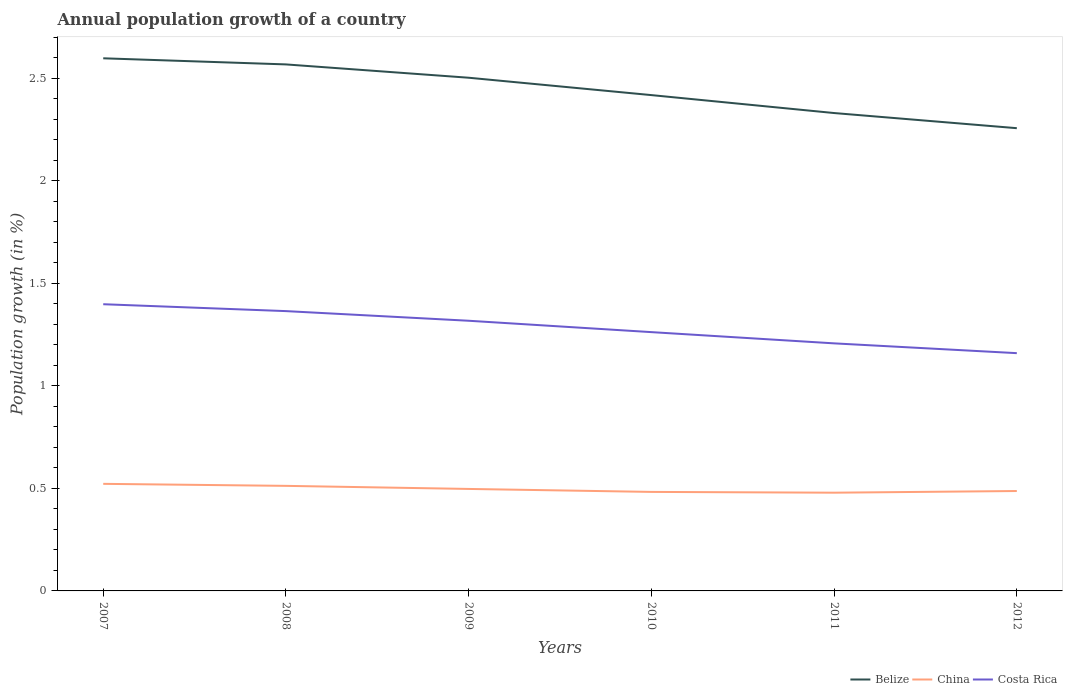How many different coloured lines are there?
Make the answer very short. 3. Does the line corresponding to Belize intersect with the line corresponding to China?
Provide a succinct answer. No. Is the number of lines equal to the number of legend labels?
Your answer should be very brief. Yes. Across all years, what is the maximum annual population growth in Costa Rica?
Give a very brief answer. 1.16. What is the total annual population growth in China in the graph?
Your answer should be compact. 0.02. What is the difference between the highest and the second highest annual population growth in China?
Your answer should be very brief. 0.04. Is the annual population growth in China strictly greater than the annual population growth in Costa Rica over the years?
Ensure brevity in your answer.  Yes. Does the graph contain any zero values?
Your answer should be compact. No. Does the graph contain grids?
Your answer should be compact. No. How are the legend labels stacked?
Your answer should be compact. Horizontal. What is the title of the graph?
Give a very brief answer. Annual population growth of a country. What is the label or title of the X-axis?
Make the answer very short. Years. What is the label or title of the Y-axis?
Your answer should be very brief. Population growth (in %). What is the Population growth (in %) in Belize in 2007?
Provide a short and direct response. 2.6. What is the Population growth (in %) of China in 2007?
Keep it short and to the point. 0.52. What is the Population growth (in %) of Costa Rica in 2007?
Your answer should be compact. 1.4. What is the Population growth (in %) of Belize in 2008?
Make the answer very short. 2.57. What is the Population growth (in %) in China in 2008?
Give a very brief answer. 0.51. What is the Population growth (in %) of Costa Rica in 2008?
Keep it short and to the point. 1.36. What is the Population growth (in %) of Belize in 2009?
Make the answer very short. 2.5. What is the Population growth (in %) of China in 2009?
Your answer should be very brief. 0.5. What is the Population growth (in %) in Costa Rica in 2009?
Your answer should be compact. 1.32. What is the Population growth (in %) of Belize in 2010?
Provide a succinct answer. 2.42. What is the Population growth (in %) of China in 2010?
Keep it short and to the point. 0.48. What is the Population growth (in %) in Costa Rica in 2010?
Provide a succinct answer. 1.26. What is the Population growth (in %) in Belize in 2011?
Keep it short and to the point. 2.33. What is the Population growth (in %) of China in 2011?
Provide a succinct answer. 0.48. What is the Population growth (in %) in Costa Rica in 2011?
Your response must be concise. 1.21. What is the Population growth (in %) in Belize in 2012?
Your answer should be very brief. 2.26. What is the Population growth (in %) of China in 2012?
Provide a succinct answer. 0.49. What is the Population growth (in %) in Costa Rica in 2012?
Your response must be concise. 1.16. Across all years, what is the maximum Population growth (in %) of Belize?
Your answer should be very brief. 2.6. Across all years, what is the maximum Population growth (in %) of China?
Make the answer very short. 0.52. Across all years, what is the maximum Population growth (in %) in Costa Rica?
Your response must be concise. 1.4. Across all years, what is the minimum Population growth (in %) in Belize?
Provide a short and direct response. 2.26. Across all years, what is the minimum Population growth (in %) in China?
Your answer should be compact. 0.48. Across all years, what is the minimum Population growth (in %) of Costa Rica?
Keep it short and to the point. 1.16. What is the total Population growth (in %) of Belize in the graph?
Your response must be concise. 14.67. What is the total Population growth (in %) of China in the graph?
Offer a very short reply. 2.98. What is the total Population growth (in %) in Costa Rica in the graph?
Your answer should be very brief. 7.71. What is the difference between the Population growth (in %) in Belize in 2007 and that in 2008?
Ensure brevity in your answer.  0.03. What is the difference between the Population growth (in %) of China in 2007 and that in 2008?
Offer a terse response. 0.01. What is the difference between the Population growth (in %) of Costa Rica in 2007 and that in 2008?
Provide a short and direct response. 0.03. What is the difference between the Population growth (in %) in Belize in 2007 and that in 2009?
Provide a short and direct response. 0.09. What is the difference between the Population growth (in %) of China in 2007 and that in 2009?
Keep it short and to the point. 0.02. What is the difference between the Population growth (in %) in Costa Rica in 2007 and that in 2009?
Your answer should be very brief. 0.08. What is the difference between the Population growth (in %) of Belize in 2007 and that in 2010?
Provide a short and direct response. 0.18. What is the difference between the Population growth (in %) in China in 2007 and that in 2010?
Your answer should be compact. 0.04. What is the difference between the Population growth (in %) in Costa Rica in 2007 and that in 2010?
Your response must be concise. 0.14. What is the difference between the Population growth (in %) of Belize in 2007 and that in 2011?
Keep it short and to the point. 0.27. What is the difference between the Population growth (in %) of China in 2007 and that in 2011?
Give a very brief answer. 0.04. What is the difference between the Population growth (in %) of Costa Rica in 2007 and that in 2011?
Your answer should be compact. 0.19. What is the difference between the Population growth (in %) in Belize in 2007 and that in 2012?
Provide a short and direct response. 0.34. What is the difference between the Population growth (in %) of China in 2007 and that in 2012?
Provide a short and direct response. 0.04. What is the difference between the Population growth (in %) of Costa Rica in 2007 and that in 2012?
Offer a terse response. 0.24. What is the difference between the Population growth (in %) in Belize in 2008 and that in 2009?
Keep it short and to the point. 0.06. What is the difference between the Population growth (in %) in China in 2008 and that in 2009?
Give a very brief answer. 0.01. What is the difference between the Population growth (in %) of Costa Rica in 2008 and that in 2009?
Keep it short and to the point. 0.05. What is the difference between the Population growth (in %) in Belize in 2008 and that in 2010?
Your answer should be compact. 0.15. What is the difference between the Population growth (in %) of China in 2008 and that in 2010?
Provide a short and direct response. 0.03. What is the difference between the Population growth (in %) in Costa Rica in 2008 and that in 2010?
Give a very brief answer. 0.1. What is the difference between the Population growth (in %) in Belize in 2008 and that in 2011?
Keep it short and to the point. 0.24. What is the difference between the Population growth (in %) of China in 2008 and that in 2011?
Provide a short and direct response. 0.03. What is the difference between the Population growth (in %) of Costa Rica in 2008 and that in 2011?
Provide a succinct answer. 0.16. What is the difference between the Population growth (in %) in Belize in 2008 and that in 2012?
Ensure brevity in your answer.  0.31. What is the difference between the Population growth (in %) in China in 2008 and that in 2012?
Provide a short and direct response. 0.03. What is the difference between the Population growth (in %) of Costa Rica in 2008 and that in 2012?
Offer a very short reply. 0.21. What is the difference between the Population growth (in %) of Belize in 2009 and that in 2010?
Make the answer very short. 0.08. What is the difference between the Population growth (in %) of China in 2009 and that in 2010?
Your answer should be compact. 0.01. What is the difference between the Population growth (in %) in Costa Rica in 2009 and that in 2010?
Your answer should be very brief. 0.06. What is the difference between the Population growth (in %) of Belize in 2009 and that in 2011?
Make the answer very short. 0.17. What is the difference between the Population growth (in %) in China in 2009 and that in 2011?
Offer a terse response. 0.02. What is the difference between the Population growth (in %) in Costa Rica in 2009 and that in 2011?
Offer a very short reply. 0.11. What is the difference between the Population growth (in %) in Belize in 2009 and that in 2012?
Make the answer very short. 0.25. What is the difference between the Population growth (in %) of China in 2009 and that in 2012?
Your response must be concise. 0.01. What is the difference between the Population growth (in %) in Costa Rica in 2009 and that in 2012?
Offer a terse response. 0.16. What is the difference between the Population growth (in %) in Belize in 2010 and that in 2011?
Give a very brief answer. 0.09. What is the difference between the Population growth (in %) of China in 2010 and that in 2011?
Keep it short and to the point. 0. What is the difference between the Population growth (in %) of Costa Rica in 2010 and that in 2011?
Your answer should be compact. 0.05. What is the difference between the Population growth (in %) of Belize in 2010 and that in 2012?
Your answer should be very brief. 0.16. What is the difference between the Population growth (in %) of China in 2010 and that in 2012?
Offer a terse response. -0. What is the difference between the Population growth (in %) in Costa Rica in 2010 and that in 2012?
Ensure brevity in your answer.  0.1. What is the difference between the Population growth (in %) in Belize in 2011 and that in 2012?
Your response must be concise. 0.07. What is the difference between the Population growth (in %) in China in 2011 and that in 2012?
Your response must be concise. -0.01. What is the difference between the Population growth (in %) in Costa Rica in 2011 and that in 2012?
Your response must be concise. 0.05. What is the difference between the Population growth (in %) in Belize in 2007 and the Population growth (in %) in China in 2008?
Offer a very short reply. 2.09. What is the difference between the Population growth (in %) of Belize in 2007 and the Population growth (in %) of Costa Rica in 2008?
Provide a short and direct response. 1.23. What is the difference between the Population growth (in %) of China in 2007 and the Population growth (in %) of Costa Rica in 2008?
Your answer should be very brief. -0.84. What is the difference between the Population growth (in %) of Belize in 2007 and the Population growth (in %) of China in 2009?
Offer a terse response. 2.1. What is the difference between the Population growth (in %) of Belize in 2007 and the Population growth (in %) of Costa Rica in 2009?
Offer a very short reply. 1.28. What is the difference between the Population growth (in %) of China in 2007 and the Population growth (in %) of Costa Rica in 2009?
Provide a short and direct response. -0.8. What is the difference between the Population growth (in %) in Belize in 2007 and the Population growth (in %) in China in 2010?
Give a very brief answer. 2.11. What is the difference between the Population growth (in %) of Belize in 2007 and the Population growth (in %) of Costa Rica in 2010?
Your response must be concise. 1.34. What is the difference between the Population growth (in %) of China in 2007 and the Population growth (in %) of Costa Rica in 2010?
Provide a succinct answer. -0.74. What is the difference between the Population growth (in %) of Belize in 2007 and the Population growth (in %) of China in 2011?
Make the answer very short. 2.12. What is the difference between the Population growth (in %) of Belize in 2007 and the Population growth (in %) of Costa Rica in 2011?
Keep it short and to the point. 1.39. What is the difference between the Population growth (in %) of China in 2007 and the Population growth (in %) of Costa Rica in 2011?
Offer a very short reply. -0.69. What is the difference between the Population growth (in %) in Belize in 2007 and the Population growth (in %) in China in 2012?
Ensure brevity in your answer.  2.11. What is the difference between the Population growth (in %) in Belize in 2007 and the Population growth (in %) in Costa Rica in 2012?
Keep it short and to the point. 1.44. What is the difference between the Population growth (in %) of China in 2007 and the Population growth (in %) of Costa Rica in 2012?
Give a very brief answer. -0.64. What is the difference between the Population growth (in %) of Belize in 2008 and the Population growth (in %) of China in 2009?
Your answer should be very brief. 2.07. What is the difference between the Population growth (in %) of Belize in 2008 and the Population growth (in %) of Costa Rica in 2009?
Offer a very short reply. 1.25. What is the difference between the Population growth (in %) of China in 2008 and the Population growth (in %) of Costa Rica in 2009?
Your answer should be compact. -0.81. What is the difference between the Population growth (in %) in Belize in 2008 and the Population growth (in %) in China in 2010?
Offer a very short reply. 2.08. What is the difference between the Population growth (in %) in Belize in 2008 and the Population growth (in %) in Costa Rica in 2010?
Offer a terse response. 1.31. What is the difference between the Population growth (in %) in China in 2008 and the Population growth (in %) in Costa Rica in 2010?
Make the answer very short. -0.75. What is the difference between the Population growth (in %) of Belize in 2008 and the Population growth (in %) of China in 2011?
Give a very brief answer. 2.09. What is the difference between the Population growth (in %) in Belize in 2008 and the Population growth (in %) in Costa Rica in 2011?
Offer a terse response. 1.36. What is the difference between the Population growth (in %) of China in 2008 and the Population growth (in %) of Costa Rica in 2011?
Provide a succinct answer. -0.7. What is the difference between the Population growth (in %) in Belize in 2008 and the Population growth (in %) in China in 2012?
Give a very brief answer. 2.08. What is the difference between the Population growth (in %) of Belize in 2008 and the Population growth (in %) of Costa Rica in 2012?
Ensure brevity in your answer.  1.41. What is the difference between the Population growth (in %) in China in 2008 and the Population growth (in %) in Costa Rica in 2012?
Your response must be concise. -0.65. What is the difference between the Population growth (in %) in Belize in 2009 and the Population growth (in %) in China in 2010?
Give a very brief answer. 2.02. What is the difference between the Population growth (in %) in Belize in 2009 and the Population growth (in %) in Costa Rica in 2010?
Provide a short and direct response. 1.24. What is the difference between the Population growth (in %) of China in 2009 and the Population growth (in %) of Costa Rica in 2010?
Offer a very short reply. -0.76. What is the difference between the Population growth (in %) of Belize in 2009 and the Population growth (in %) of China in 2011?
Provide a short and direct response. 2.02. What is the difference between the Population growth (in %) of Belize in 2009 and the Population growth (in %) of Costa Rica in 2011?
Offer a terse response. 1.3. What is the difference between the Population growth (in %) of China in 2009 and the Population growth (in %) of Costa Rica in 2011?
Provide a short and direct response. -0.71. What is the difference between the Population growth (in %) of Belize in 2009 and the Population growth (in %) of China in 2012?
Offer a terse response. 2.02. What is the difference between the Population growth (in %) in Belize in 2009 and the Population growth (in %) in Costa Rica in 2012?
Offer a very short reply. 1.34. What is the difference between the Population growth (in %) in China in 2009 and the Population growth (in %) in Costa Rica in 2012?
Provide a short and direct response. -0.66. What is the difference between the Population growth (in %) in Belize in 2010 and the Population growth (in %) in China in 2011?
Ensure brevity in your answer.  1.94. What is the difference between the Population growth (in %) of Belize in 2010 and the Population growth (in %) of Costa Rica in 2011?
Give a very brief answer. 1.21. What is the difference between the Population growth (in %) of China in 2010 and the Population growth (in %) of Costa Rica in 2011?
Make the answer very short. -0.72. What is the difference between the Population growth (in %) of Belize in 2010 and the Population growth (in %) of China in 2012?
Ensure brevity in your answer.  1.93. What is the difference between the Population growth (in %) in Belize in 2010 and the Population growth (in %) in Costa Rica in 2012?
Offer a terse response. 1.26. What is the difference between the Population growth (in %) in China in 2010 and the Population growth (in %) in Costa Rica in 2012?
Offer a very short reply. -0.68. What is the difference between the Population growth (in %) in Belize in 2011 and the Population growth (in %) in China in 2012?
Offer a terse response. 1.84. What is the difference between the Population growth (in %) in Belize in 2011 and the Population growth (in %) in Costa Rica in 2012?
Your response must be concise. 1.17. What is the difference between the Population growth (in %) of China in 2011 and the Population growth (in %) of Costa Rica in 2012?
Ensure brevity in your answer.  -0.68. What is the average Population growth (in %) in Belize per year?
Your answer should be compact. 2.45. What is the average Population growth (in %) of China per year?
Offer a very short reply. 0.5. What is the average Population growth (in %) in Costa Rica per year?
Ensure brevity in your answer.  1.28. In the year 2007, what is the difference between the Population growth (in %) of Belize and Population growth (in %) of China?
Provide a succinct answer. 2.08. In the year 2007, what is the difference between the Population growth (in %) in Belize and Population growth (in %) in Costa Rica?
Give a very brief answer. 1.2. In the year 2007, what is the difference between the Population growth (in %) of China and Population growth (in %) of Costa Rica?
Make the answer very short. -0.88. In the year 2008, what is the difference between the Population growth (in %) in Belize and Population growth (in %) in China?
Your answer should be very brief. 2.06. In the year 2008, what is the difference between the Population growth (in %) in Belize and Population growth (in %) in Costa Rica?
Your answer should be very brief. 1.2. In the year 2008, what is the difference between the Population growth (in %) of China and Population growth (in %) of Costa Rica?
Keep it short and to the point. -0.85. In the year 2009, what is the difference between the Population growth (in %) of Belize and Population growth (in %) of China?
Offer a very short reply. 2.01. In the year 2009, what is the difference between the Population growth (in %) of Belize and Population growth (in %) of Costa Rica?
Keep it short and to the point. 1.19. In the year 2009, what is the difference between the Population growth (in %) in China and Population growth (in %) in Costa Rica?
Provide a succinct answer. -0.82. In the year 2010, what is the difference between the Population growth (in %) of Belize and Population growth (in %) of China?
Keep it short and to the point. 1.94. In the year 2010, what is the difference between the Population growth (in %) in Belize and Population growth (in %) in Costa Rica?
Keep it short and to the point. 1.16. In the year 2010, what is the difference between the Population growth (in %) of China and Population growth (in %) of Costa Rica?
Ensure brevity in your answer.  -0.78. In the year 2011, what is the difference between the Population growth (in %) in Belize and Population growth (in %) in China?
Keep it short and to the point. 1.85. In the year 2011, what is the difference between the Population growth (in %) in Belize and Population growth (in %) in Costa Rica?
Provide a short and direct response. 1.12. In the year 2011, what is the difference between the Population growth (in %) of China and Population growth (in %) of Costa Rica?
Offer a very short reply. -0.73. In the year 2012, what is the difference between the Population growth (in %) in Belize and Population growth (in %) in China?
Offer a terse response. 1.77. In the year 2012, what is the difference between the Population growth (in %) in Belize and Population growth (in %) in Costa Rica?
Offer a terse response. 1.1. In the year 2012, what is the difference between the Population growth (in %) in China and Population growth (in %) in Costa Rica?
Offer a terse response. -0.67. What is the ratio of the Population growth (in %) in Belize in 2007 to that in 2008?
Make the answer very short. 1.01. What is the ratio of the Population growth (in %) of China in 2007 to that in 2008?
Ensure brevity in your answer.  1.02. What is the ratio of the Population growth (in %) in Costa Rica in 2007 to that in 2008?
Keep it short and to the point. 1.02. What is the ratio of the Population growth (in %) in Belize in 2007 to that in 2009?
Ensure brevity in your answer.  1.04. What is the ratio of the Population growth (in %) in Costa Rica in 2007 to that in 2009?
Your response must be concise. 1.06. What is the ratio of the Population growth (in %) of Belize in 2007 to that in 2010?
Your answer should be compact. 1.07. What is the ratio of the Population growth (in %) of China in 2007 to that in 2010?
Offer a very short reply. 1.08. What is the ratio of the Population growth (in %) of Costa Rica in 2007 to that in 2010?
Keep it short and to the point. 1.11. What is the ratio of the Population growth (in %) in Belize in 2007 to that in 2011?
Keep it short and to the point. 1.11. What is the ratio of the Population growth (in %) in China in 2007 to that in 2011?
Offer a very short reply. 1.09. What is the ratio of the Population growth (in %) in Costa Rica in 2007 to that in 2011?
Make the answer very short. 1.16. What is the ratio of the Population growth (in %) in Belize in 2007 to that in 2012?
Provide a succinct answer. 1.15. What is the ratio of the Population growth (in %) in China in 2007 to that in 2012?
Your response must be concise. 1.07. What is the ratio of the Population growth (in %) in Costa Rica in 2007 to that in 2012?
Offer a terse response. 1.21. What is the ratio of the Population growth (in %) of Belize in 2008 to that in 2009?
Make the answer very short. 1.03. What is the ratio of the Population growth (in %) in China in 2008 to that in 2009?
Your response must be concise. 1.03. What is the ratio of the Population growth (in %) of Costa Rica in 2008 to that in 2009?
Ensure brevity in your answer.  1.04. What is the ratio of the Population growth (in %) of Belize in 2008 to that in 2010?
Offer a very short reply. 1.06. What is the ratio of the Population growth (in %) of China in 2008 to that in 2010?
Offer a very short reply. 1.06. What is the ratio of the Population growth (in %) in Costa Rica in 2008 to that in 2010?
Your answer should be compact. 1.08. What is the ratio of the Population growth (in %) in Belize in 2008 to that in 2011?
Offer a very short reply. 1.1. What is the ratio of the Population growth (in %) in China in 2008 to that in 2011?
Keep it short and to the point. 1.07. What is the ratio of the Population growth (in %) of Costa Rica in 2008 to that in 2011?
Your answer should be compact. 1.13. What is the ratio of the Population growth (in %) in Belize in 2008 to that in 2012?
Provide a short and direct response. 1.14. What is the ratio of the Population growth (in %) of China in 2008 to that in 2012?
Make the answer very short. 1.05. What is the ratio of the Population growth (in %) of Costa Rica in 2008 to that in 2012?
Keep it short and to the point. 1.18. What is the ratio of the Population growth (in %) in Belize in 2009 to that in 2010?
Provide a short and direct response. 1.03. What is the ratio of the Population growth (in %) in China in 2009 to that in 2010?
Offer a terse response. 1.03. What is the ratio of the Population growth (in %) of Costa Rica in 2009 to that in 2010?
Provide a succinct answer. 1.04. What is the ratio of the Population growth (in %) in Belize in 2009 to that in 2011?
Your response must be concise. 1.07. What is the ratio of the Population growth (in %) in China in 2009 to that in 2011?
Provide a short and direct response. 1.04. What is the ratio of the Population growth (in %) of Costa Rica in 2009 to that in 2011?
Give a very brief answer. 1.09. What is the ratio of the Population growth (in %) of Belize in 2009 to that in 2012?
Your response must be concise. 1.11. What is the ratio of the Population growth (in %) in China in 2009 to that in 2012?
Make the answer very short. 1.02. What is the ratio of the Population growth (in %) in Costa Rica in 2009 to that in 2012?
Offer a terse response. 1.14. What is the ratio of the Population growth (in %) of Belize in 2010 to that in 2011?
Ensure brevity in your answer.  1.04. What is the ratio of the Population growth (in %) of China in 2010 to that in 2011?
Your answer should be very brief. 1.01. What is the ratio of the Population growth (in %) in Costa Rica in 2010 to that in 2011?
Offer a terse response. 1.05. What is the ratio of the Population growth (in %) of Belize in 2010 to that in 2012?
Offer a terse response. 1.07. What is the ratio of the Population growth (in %) of China in 2010 to that in 2012?
Offer a very short reply. 0.99. What is the ratio of the Population growth (in %) in Costa Rica in 2010 to that in 2012?
Your answer should be very brief. 1.09. What is the ratio of the Population growth (in %) of Belize in 2011 to that in 2012?
Make the answer very short. 1.03. What is the ratio of the Population growth (in %) of China in 2011 to that in 2012?
Your answer should be compact. 0.98. What is the ratio of the Population growth (in %) of Costa Rica in 2011 to that in 2012?
Your answer should be very brief. 1.04. What is the difference between the highest and the second highest Population growth (in %) of Belize?
Provide a succinct answer. 0.03. What is the difference between the highest and the second highest Population growth (in %) of China?
Offer a terse response. 0.01. What is the difference between the highest and the second highest Population growth (in %) in Costa Rica?
Make the answer very short. 0.03. What is the difference between the highest and the lowest Population growth (in %) in Belize?
Provide a succinct answer. 0.34. What is the difference between the highest and the lowest Population growth (in %) in China?
Keep it short and to the point. 0.04. What is the difference between the highest and the lowest Population growth (in %) of Costa Rica?
Ensure brevity in your answer.  0.24. 